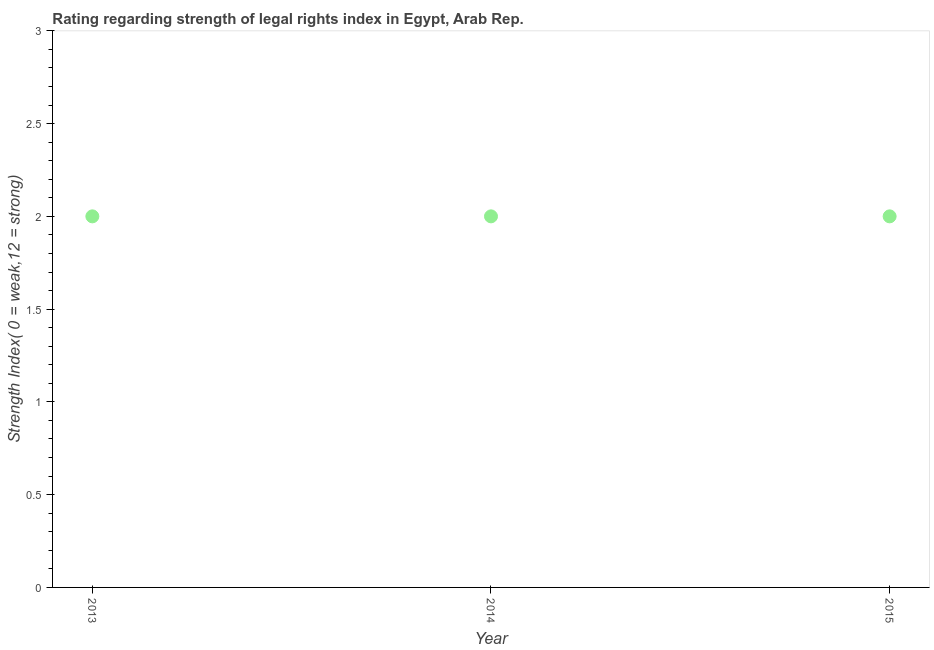What is the strength of legal rights index in 2014?
Give a very brief answer. 2. Across all years, what is the maximum strength of legal rights index?
Your answer should be very brief. 2. Across all years, what is the minimum strength of legal rights index?
Give a very brief answer. 2. In which year was the strength of legal rights index maximum?
Make the answer very short. 2013. What is the sum of the strength of legal rights index?
Provide a short and direct response. 6. What is the difference between the strength of legal rights index in 2013 and 2015?
Your answer should be compact. 0. What is the median strength of legal rights index?
Offer a terse response. 2. Do a majority of the years between 2014 and 2013 (inclusive) have strength of legal rights index greater than 2.8 ?
Your answer should be very brief. No. What is the ratio of the strength of legal rights index in 2014 to that in 2015?
Provide a short and direct response. 1. Is the strength of legal rights index in 2013 less than that in 2014?
Offer a very short reply. No. What is the difference between the highest and the second highest strength of legal rights index?
Provide a short and direct response. 0. Is the sum of the strength of legal rights index in 2013 and 2015 greater than the maximum strength of legal rights index across all years?
Offer a very short reply. Yes. What is the difference between the highest and the lowest strength of legal rights index?
Give a very brief answer. 0. What is the difference between two consecutive major ticks on the Y-axis?
Provide a succinct answer. 0.5. Does the graph contain any zero values?
Offer a very short reply. No. What is the title of the graph?
Offer a terse response. Rating regarding strength of legal rights index in Egypt, Arab Rep. What is the label or title of the Y-axis?
Make the answer very short. Strength Index( 0 = weak,12 = strong). What is the Strength Index( 0 = weak,12 = strong) in 2013?
Provide a short and direct response. 2. What is the Strength Index( 0 = weak,12 = strong) in 2014?
Keep it short and to the point. 2. What is the Strength Index( 0 = weak,12 = strong) in 2015?
Your response must be concise. 2. What is the difference between the Strength Index( 0 = weak,12 = strong) in 2013 and 2014?
Give a very brief answer. 0. What is the ratio of the Strength Index( 0 = weak,12 = strong) in 2013 to that in 2015?
Offer a terse response. 1. What is the ratio of the Strength Index( 0 = weak,12 = strong) in 2014 to that in 2015?
Offer a terse response. 1. 